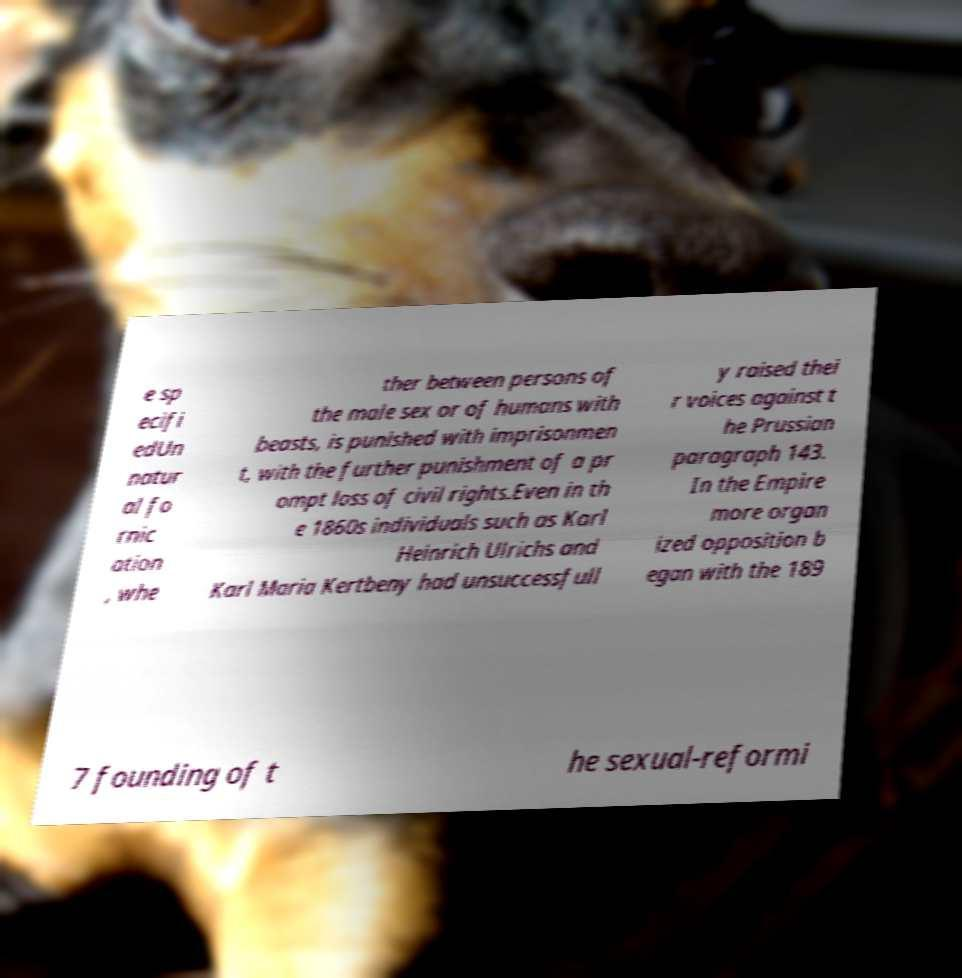Could you assist in decoding the text presented in this image and type it out clearly? e sp ecifi edUn natur al fo rnic ation , whe ther between persons of the male sex or of humans with beasts, is punished with imprisonmen t, with the further punishment of a pr ompt loss of civil rights.Even in th e 1860s individuals such as Karl Heinrich Ulrichs and Karl Maria Kertbeny had unsuccessfull y raised thei r voices against t he Prussian paragraph 143. In the Empire more organ ized opposition b egan with the 189 7 founding of t he sexual-reformi 